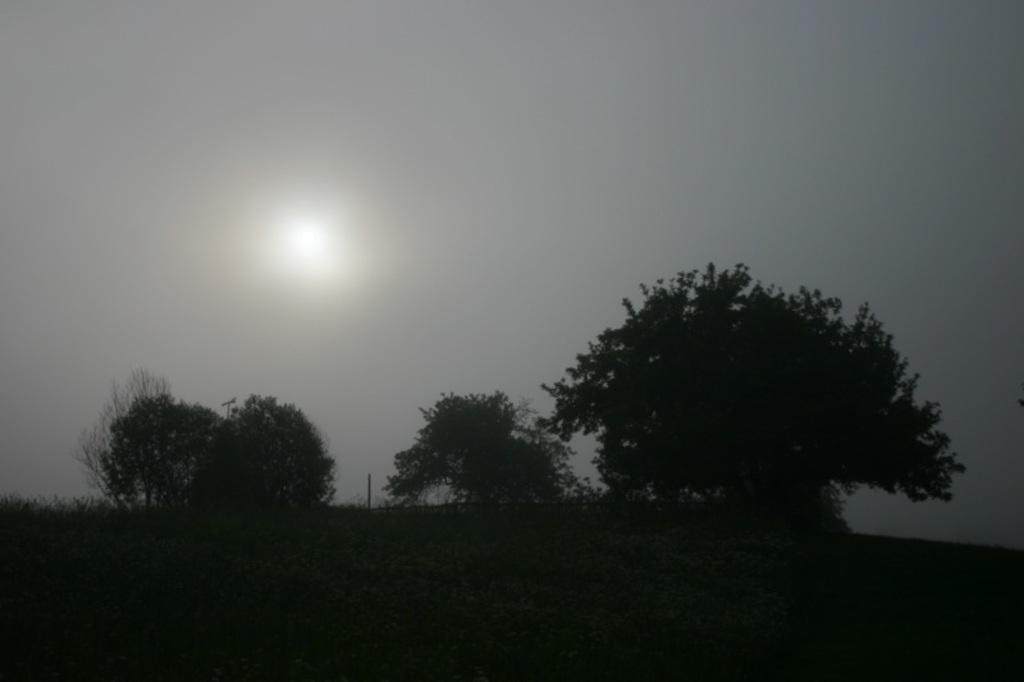Can you describe this image briefly? This picture might be taken outside of the city. In this image, in the background, we can see some trees and pole. On the top, we can see a sky which is cloudy, we can also see a moon, at the bottom, we can see black color. 